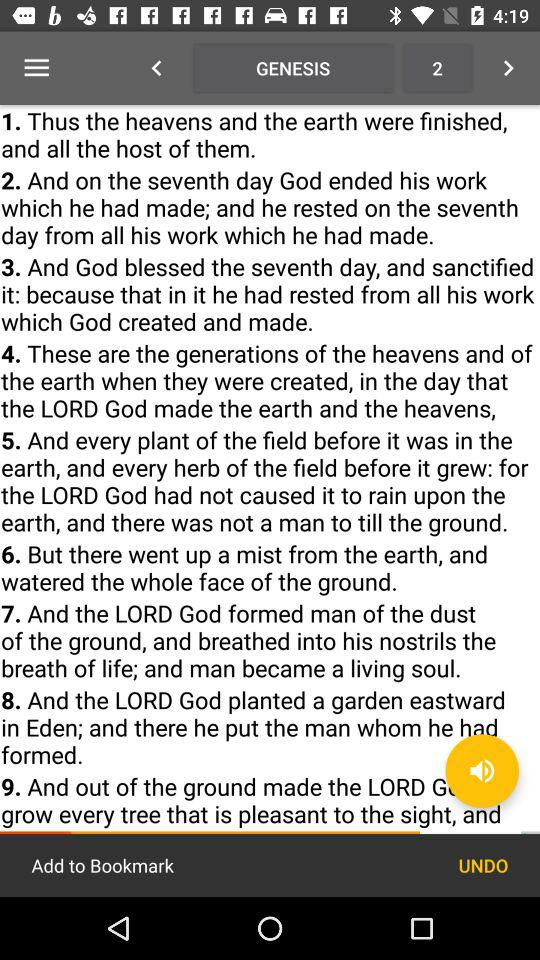What is the current chapter number of "GENESIS" shown on the screen? The current chapter number of "GENESIS" is 2. 